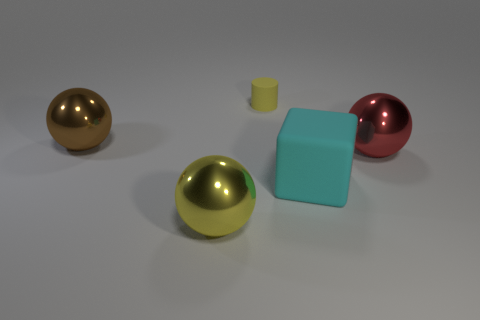Is there a small shiny cylinder of the same color as the rubber cylinder?
Your response must be concise. No. Does the tiny thing have the same shape as the cyan thing?
Your answer should be compact. No. What number of tiny objects are yellow matte cylinders or red spheres?
Offer a very short reply. 1. What color is the other tiny object that is made of the same material as the cyan object?
Make the answer very short. Yellow. What number of big yellow things have the same material as the red ball?
Your answer should be very brief. 1. Do the object on the right side of the large rubber object and the yellow thing in front of the large brown object have the same size?
Give a very brief answer. Yes. The big object to the left of the big metallic sphere that is in front of the red ball is made of what material?
Ensure brevity in your answer.  Metal. Are there fewer small cylinders that are to the left of the red object than brown things that are on the right side of the big yellow shiny ball?
Provide a short and direct response. No. There is a big object that is the same color as the small matte cylinder; what is it made of?
Offer a very short reply. Metal. Is there any other thing that is the same shape as the small thing?
Offer a very short reply. No. 